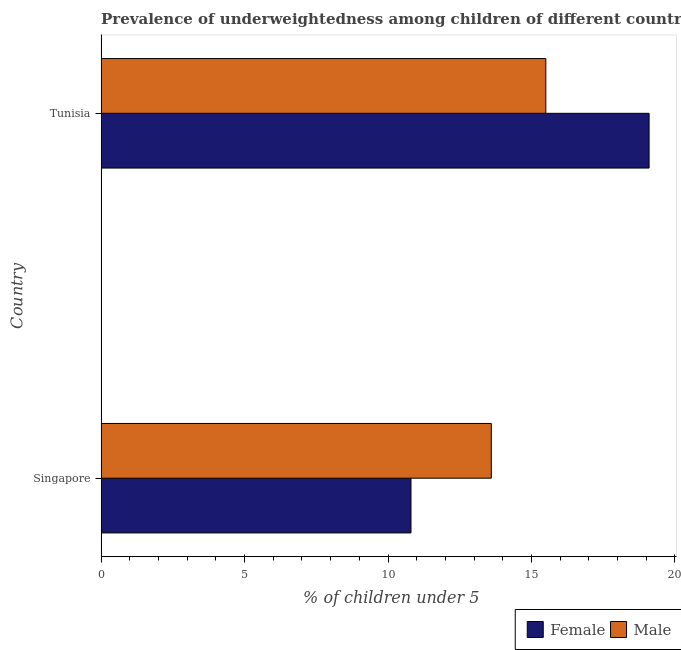How many different coloured bars are there?
Your answer should be very brief. 2. Are the number of bars per tick equal to the number of legend labels?
Your response must be concise. Yes. How many bars are there on the 1st tick from the bottom?
Keep it short and to the point. 2. What is the label of the 2nd group of bars from the top?
Provide a short and direct response. Singapore. In how many cases, is the number of bars for a given country not equal to the number of legend labels?
Give a very brief answer. 0. What is the percentage of underweighted female children in Tunisia?
Provide a succinct answer. 19.1. Across all countries, what is the minimum percentage of underweighted male children?
Give a very brief answer. 13.6. In which country was the percentage of underweighted female children maximum?
Keep it short and to the point. Tunisia. In which country was the percentage of underweighted female children minimum?
Your response must be concise. Singapore. What is the total percentage of underweighted female children in the graph?
Provide a short and direct response. 29.9. What is the difference between the percentage of underweighted female children in Singapore and that in Tunisia?
Your answer should be compact. -8.3. What is the difference between the percentage of underweighted female children in Singapore and the percentage of underweighted male children in Tunisia?
Keep it short and to the point. -4.7. What is the average percentage of underweighted female children per country?
Provide a short and direct response. 14.95. What is the difference between the percentage of underweighted male children and percentage of underweighted female children in Singapore?
Offer a terse response. 2.8. What is the ratio of the percentage of underweighted male children in Singapore to that in Tunisia?
Your answer should be compact. 0.88. Is the percentage of underweighted male children in Singapore less than that in Tunisia?
Your response must be concise. Yes. What does the 2nd bar from the top in Tunisia represents?
Make the answer very short. Female. What does the 1st bar from the bottom in Tunisia represents?
Keep it short and to the point. Female. Are all the bars in the graph horizontal?
Offer a very short reply. Yes. How many countries are there in the graph?
Offer a very short reply. 2. What is the difference between two consecutive major ticks on the X-axis?
Provide a succinct answer. 5. Are the values on the major ticks of X-axis written in scientific E-notation?
Provide a succinct answer. No. How many legend labels are there?
Keep it short and to the point. 2. What is the title of the graph?
Provide a short and direct response. Prevalence of underweightedness among children of different countries with age under 5 years. Does "Under five" appear as one of the legend labels in the graph?
Your answer should be compact. No. What is the label or title of the X-axis?
Give a very brief answer.  % of children under 5. What is the label or title of the Y-axis?
Provide a succinct answer. Country. What is the  % of children under 5 in Female in Singapore?
Your answer should be very brief. 10.8. What is the  % of children under 5 of Male in Singapore?
Give a very brief answer. 13.6. What is the  % of children under 5 in Female in Tunisia?
Provide a short and direct response. 19.1. What is the  % of children under 5 in Male in Tunisia?
Make the answer very short. 15.5. Across all countries, what is the maximum  % of children under 5 in Female?
Keep it short and to the point. 19.1. Across all countries, what is the minimum  % of children under 5 of Female?
Offer a very short reply. 10.8. Across all countries, what is the minimum  % of children under 5 in Male?
Provide a succinct answer. 13.6. What is the total  % of children under 5 of Female in the graph?
Provide a succinct answer. 29.9. What is the total  % of children under 5 in Male in the graph?
Ensure brevity in your answer.  29.1. What is the difference between the  % of children under 5 of Female in Singapore and that in Tunisia?
Offer a terse response. -8.3. What is the difference between the  % of children under 5 in Female in Singapore and the  % of children under 5 in Male in Tunisia?
Offer a very short reply. -4.7. What is the average  % of children under 5 of Female per country?
Ensure brevity in your answer.  14.95. What is the average  % of children under 5 in Male per country?
Give a very brief answer. 14.55. What is the difference between the  % of children under 5 in Female and  % of children under 5 in Male in Singapore?
Your answer should be very brief. -2.8. What is the difference between the  % of children under 5 of Female and  % of children under 5 of Male in Tunisia?
Offer a terse response. 3.6. What is the ratio of the  % of children under 5 in Female in Singapore to that in Tunisia?
Provide a short and direct response. 0.57. What is the ratio of the  % of children under 5 of Male in Singapore to that in Tunisia?
Give a very brief answer. 0.88. What is the difference between the highest and the second highest  % of children under 5 of Female?
Your answer should be compact. 8.3. 